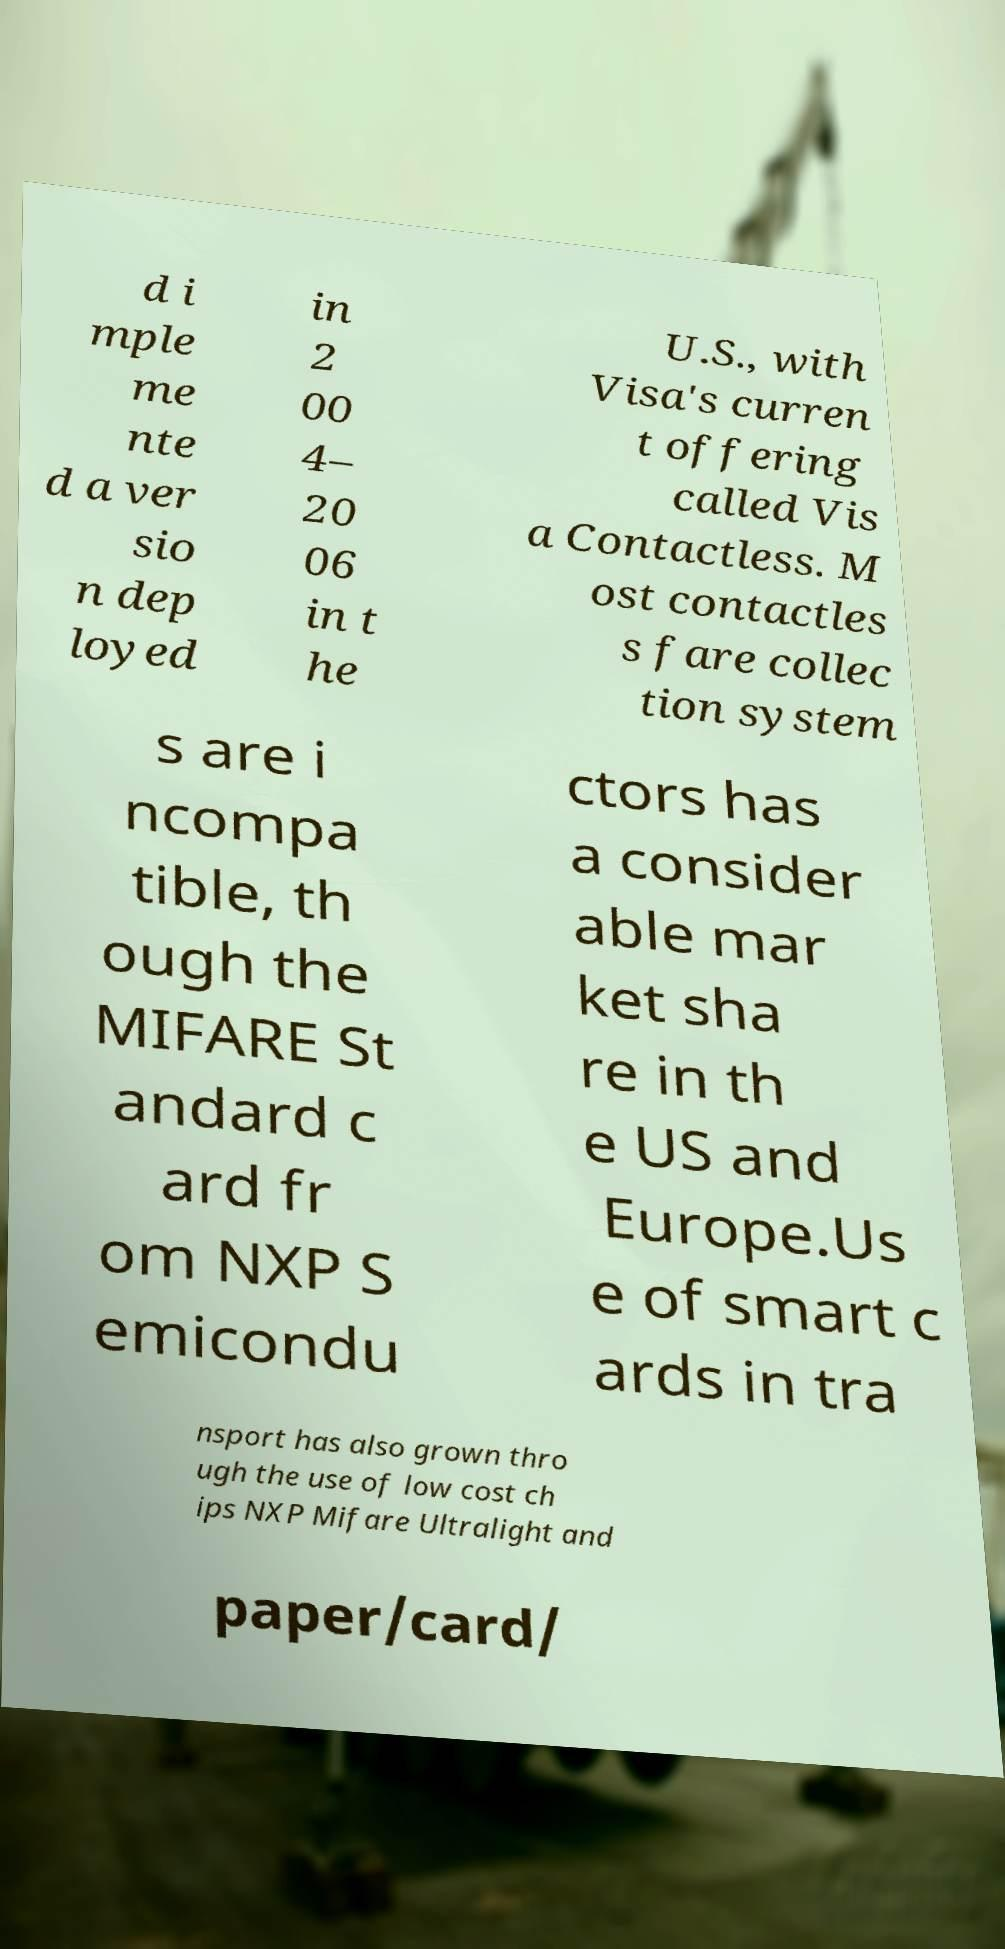I need the written content from this picture converted into text. Can you do that? d i mple me nte d a ver sio n dep loyed in 2 00 4– 20 06 in t he U.S., with Visa's curren t offering called Vis a Contactless. M ost contactles s fare collec tion system s are i ncompa tible, th ough the MIFARE St andard c ard fr om NXP S emicondu ctors has a consider able mar ket sha re in th e US and Europe.Us e of smart c ards in tra nsport has also grown thro ugh the use of low cost ch ips NXP Mifare Ultralight and paper/card/ 